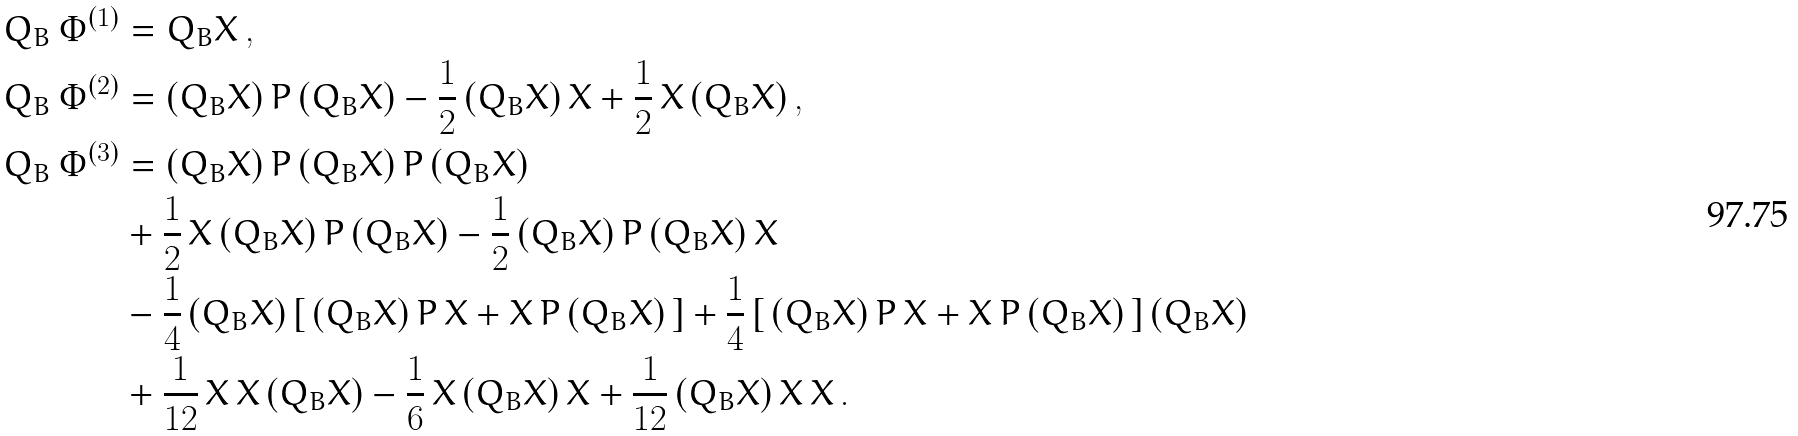Convert formula to latex. <formula><loc_0><loc_0><loc_500><loc_500>Q _ { B } \, \Phi ^ { ( 1 ) } & = Q _ { B } X \, , \\ Q _ { B } \, \Phi ^ { ( 2 ) } & = ( Q _ { B } X ) \, P \, ( Q _ { B } X ) - \frac { 1 } { 2 } \, ( Q _ { B } X ) \, X + \frac { 1 } { 2 } \, X \, ( Q _ { B } X ) \, , \\ Q _ { B } \, \Phi ^ { ( 3 ) } & = ( Q _ { B } X ) \, P \, ( Q _ { B } X ) \, P \, ( Q _ { B } X ) \\ & + \frac { 1 } { 2 } \, X \, ( Q _ { B } X ) \, P \, ( Q _ { B } X ) - \frac { 1 } { 2 } \, ( Q _ { B } X ) \, P \, ( Q _ { B } X ) \, X \\ & - \frac { 1 } { 4 } \, ( Q _ { B } X ) \, [ \, ( Q _ { B } X ) \, P \, X + X \, P \, ( Q _ { B } X ) \, ] + \frac { 1 } { 4 } \, [ \, ( Q _ { B } X ) \, P \, X + X \, P \, ( Q _ { B } X ) \, ] \, ( Q _ { B } X ) \\ & + \frac { 1 } { 1 2 } \, X \, X \, ( Q _ { B } X ) - \frac { 1 } { 6 } \, X \, ( Q _ { B } X ) \, X + \frac { 1 } { 1 2 } \, ( Q _ { B } X ) \, X \, X \, .</formula> 